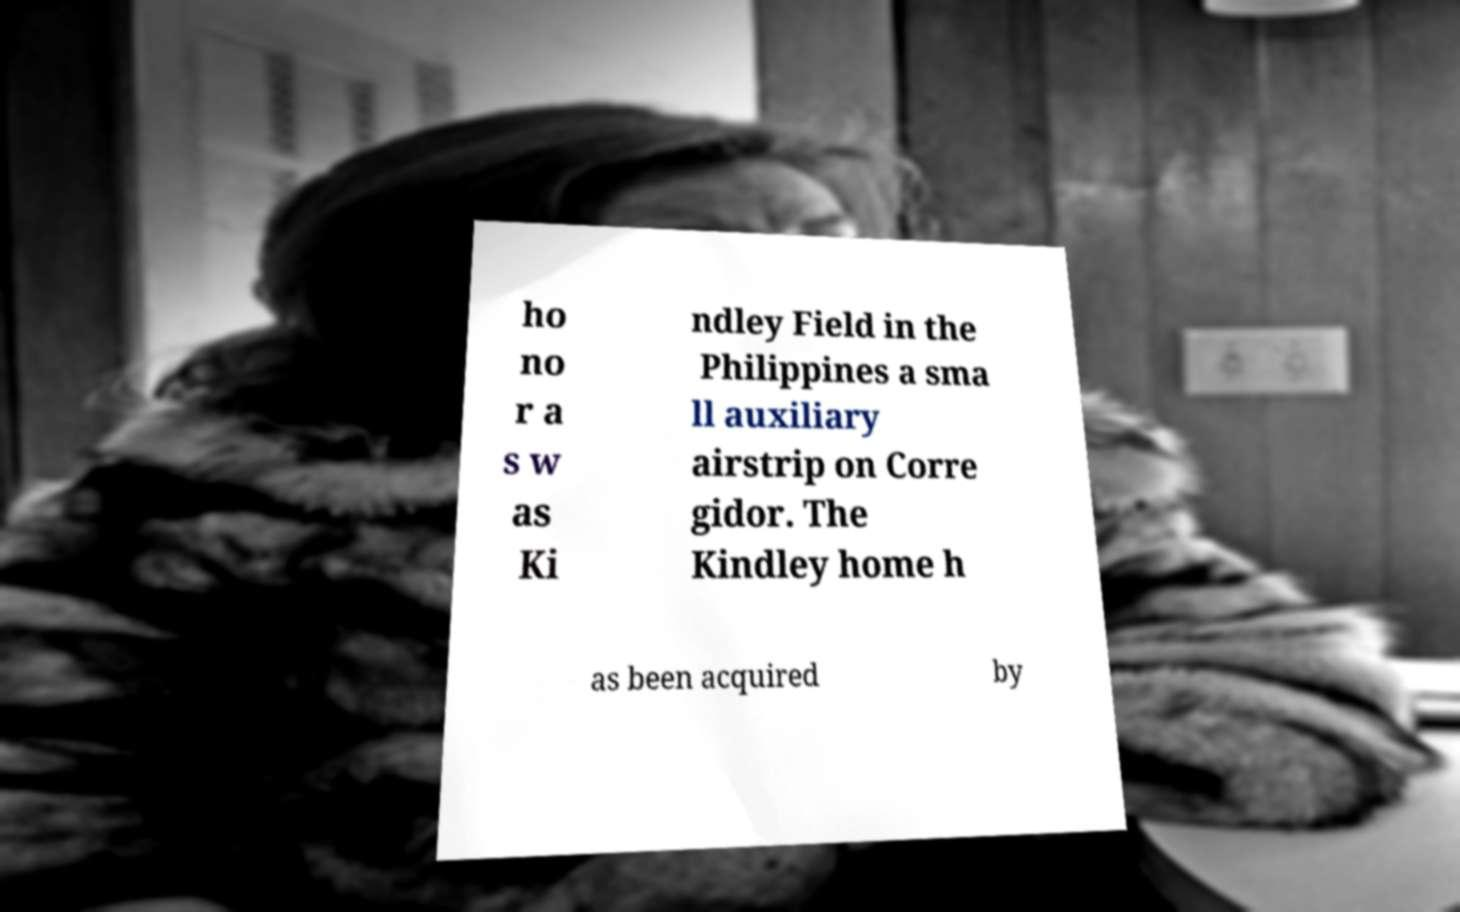Could you assist in decoding the text presented in this image and type it out clearly? ho no r a s w as Ki ndley Field in the Philippines a sma ll auxiliary airstrip on Corre gidor. The Kindley home h as been acquired by 